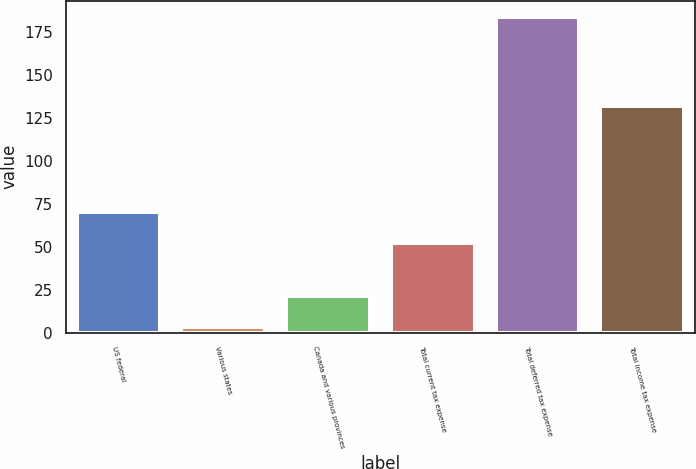Convert chart. <chart><loc_0><loc_0><loc_500><loc_500><bar_chart><fcel>US federal<fcel>Various states<fcel>Canada and various provinces<fcel>Total current tax expense<fcel>Total deferred tax expense<fcel>Total income tax expense<nl><fcel>70.1<fcel>3<fcel>21.1<fcel>52<fcel>184<fcel>132<nl></chart> 